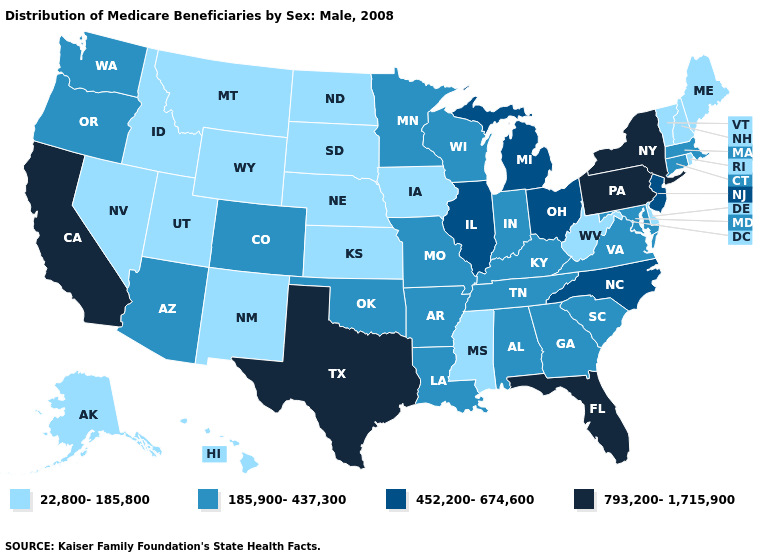Does Maryland have a lower value than Washington?
Quick response, please. No. Which states have the lowest value in the USA?
Quick response, please. Alaska, Delaware, Hawaii, Idaho, Iowa, Kansas, Maine, Mississippi, Montana, Nebraska, Nevada, New Hampshire, New Mexico, North Dakota, Rhode Island, South Dakota, Utah, Vermont, West Virginia, Wyoming. Among the states that border Utah , which have the lowest value?
Be succinct. Idaho, Nevada, New Mexico, Wyoming. Does West Virginia have a lower value than Massachusetts?
Concise answer only. Yes. What is the value of New Mexico?
Keep it brief. 22,800-185,800. Which states have the lowest value in the Northeast?
Answer briefly. Maine, New Hampshire, Rhode Island, Vermont. Does Hawaii have the lowest value in the West?
Quick response, please. Yes. Among the states that border Michigan , which have the highest value?
Quick response, please. Ohio. Does Alaska have a higher value than New Mexico?
Give a very brief answer. No. Which states hav the highest value in the MidWest?
Answer briefly. Illinois, Michigan, Ohio. What is the value of Kentucky?
Short answer required. 185,900-437,300. Does New Jersey have a higher value than Illinois?
Answer briefly. No. Does the first symbol in the legend represent the smallest category?
Give a very brief answer. Yes. Name the states that have a value in the range 793,200-1,715,900?
Concise answer only. California, Florida, New York, Pennsylvania, Texas. How many symbols are there in the legend?
Write a very short answer. 4. 